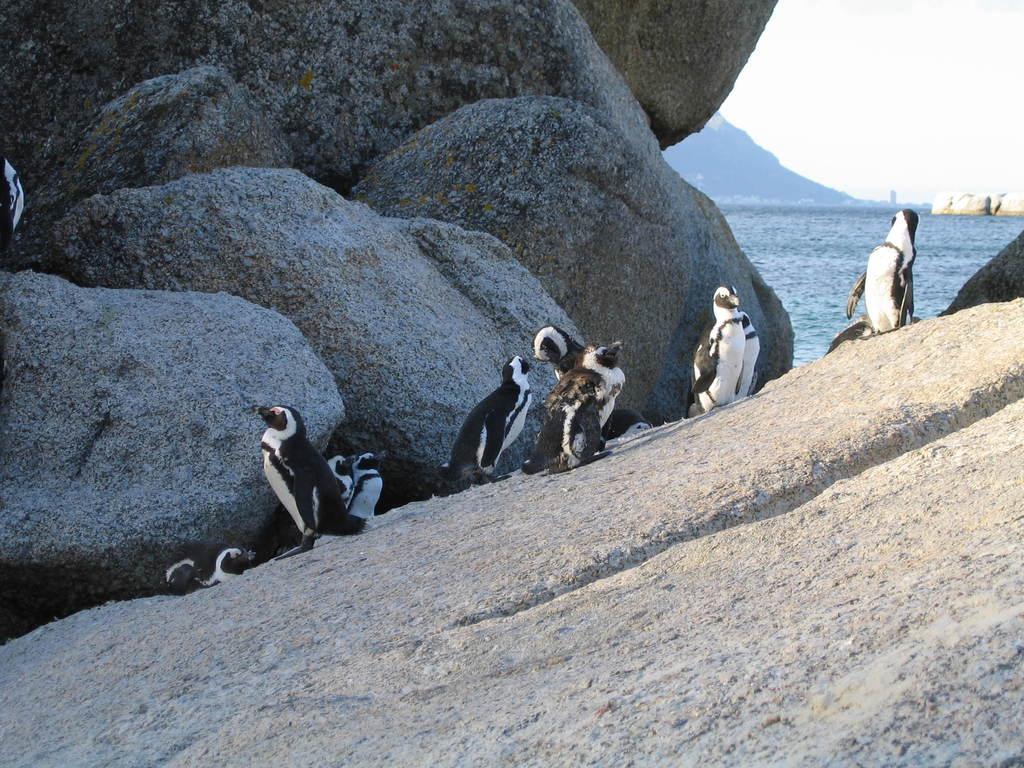Could you give a brief overview of what you see in this image? In this picture we can see penguins on a rock and in the background we can see rocks, water, mountains, sky. 